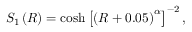Convert formula to latex. <formula><loc_0><loc_0><loc_500><loc_500>S _ { 1 } \left ( R \right ) = \cosh \left [ \left ( R + 0 . 0 5 \right ) ^ { \alpha } \right ] ^ { - 2 } ,</formula> 